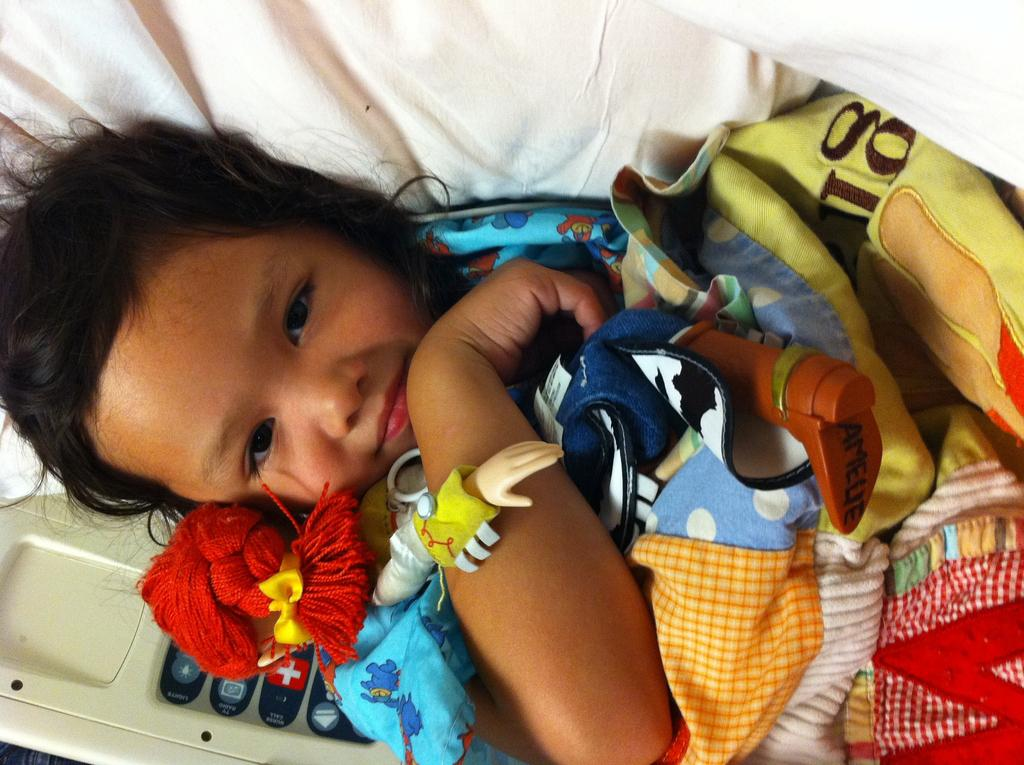<image>
Describe the image concisely. child with a doll and a blanket with letter g on it 